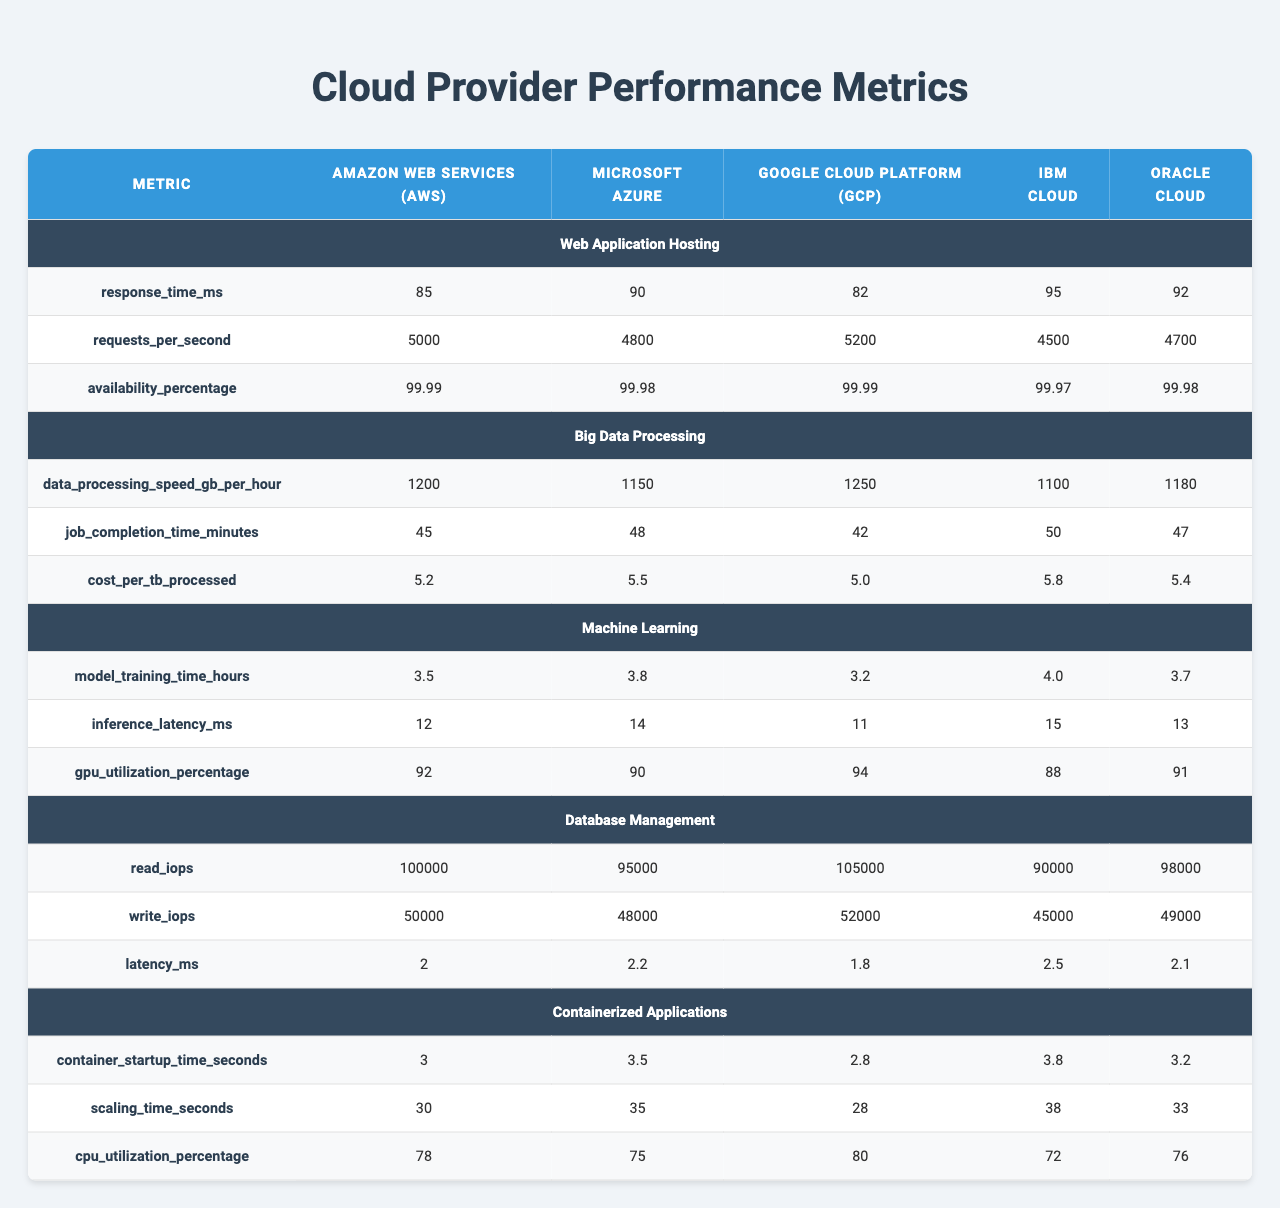What is the response time of Google Cloud Platform for web application hosting? According to the table, the response time for Google Cloud Platform under the web application hosting workload is listed as 82 milliseconds.
Answer: 82 milliseconds Which cloud provider has the highest data processing speed for Big Data Processing? The data processing speed for Big Data Processing is compared across the providers. Google Cloud Platform has the highest speed at 1250 GB per hour.
Answer: Google Cloud Platform What is the availability percentage of Microsoft Azure for web application hosting? The availability percentage for Microsoft Azure under the web application hosting is shown in the table as 99.98%.
Answer: 99.98% Which cloud provider offers the lowest cost per terabyte processed for Big Data Processing? The table shows the cost per terabyte for each cloud provider. Google Cloud Platform has the lowest cost at $5.00 per TB.
Answer: Google Cloud Platform What is the average container startup time across all providers? To find the average container startup time, we add the values: (3 + 3.5 + 2.8 + 3.8 + 3.2) = 16.3 seconds. Dividing this by 5 (the number of providers) gives us 16.3 / 5 = 3.26 seconds as the average.
Answer: 3.26 seconds Is the inference latency for Machine Learning lower in AWS compared to IBM Cloud? AWS has an inference latency of 12 milliseconds for Machine Learning and IBM Cloud has 15 milliseconds. Since 12 is less than 15, the statement is true.
Answer: Yes How much higher is the read IOPS of Google Cloud Platform compared to Microsoft Azure in Database Management? Google Cloud Platform has a read IOPS of 105,000 while Microsoft Azure has 95,000. The difference is calculated as 105,000 - 95,000 = 10,000.
Answer: 10,000 IOPS Which cloud service provider has the highest GPU utilization percentage for Machine Learning? After comparing the GPU utilization percentages listed for Machine Learning, Google Cloud Platform has the highest at 94%.
Answer: Google Cloud Platform If you were to sort the cloud providers by their job completion time for Big Data Processing, which one would rank first? The job completion times are as follows: AWS 45 minutes, GCP 42 minutes, Azure 48 minutes, IBM 50 minutes, Oracle 47 minutes. The lowest time is GCP at 42 minutes, so it ranks first.
Answer: Google Cloud Platform What can be inferred about the relation between CPU utilization and container startup time across the providers? Observing the data: AWS has a CPU utilization of 78% with a startup time of 3 seconds; GCP has 80% CPU utilization with 2.8 seconds startup. Higher CPU utilization does not directly correlate with longer startup times here, suggesting other factors influence startup time.
Answer: There is no direct correlation Which cloud provider has a better performance in terms of both requests per second and availability percentage in web application hosting? Analyzing both metrics, Google Cloud Platform has 5200 requests per second and 99.99% availability, which are the highest in both categories compared to the others.
Answer: Google Cloud Platform 